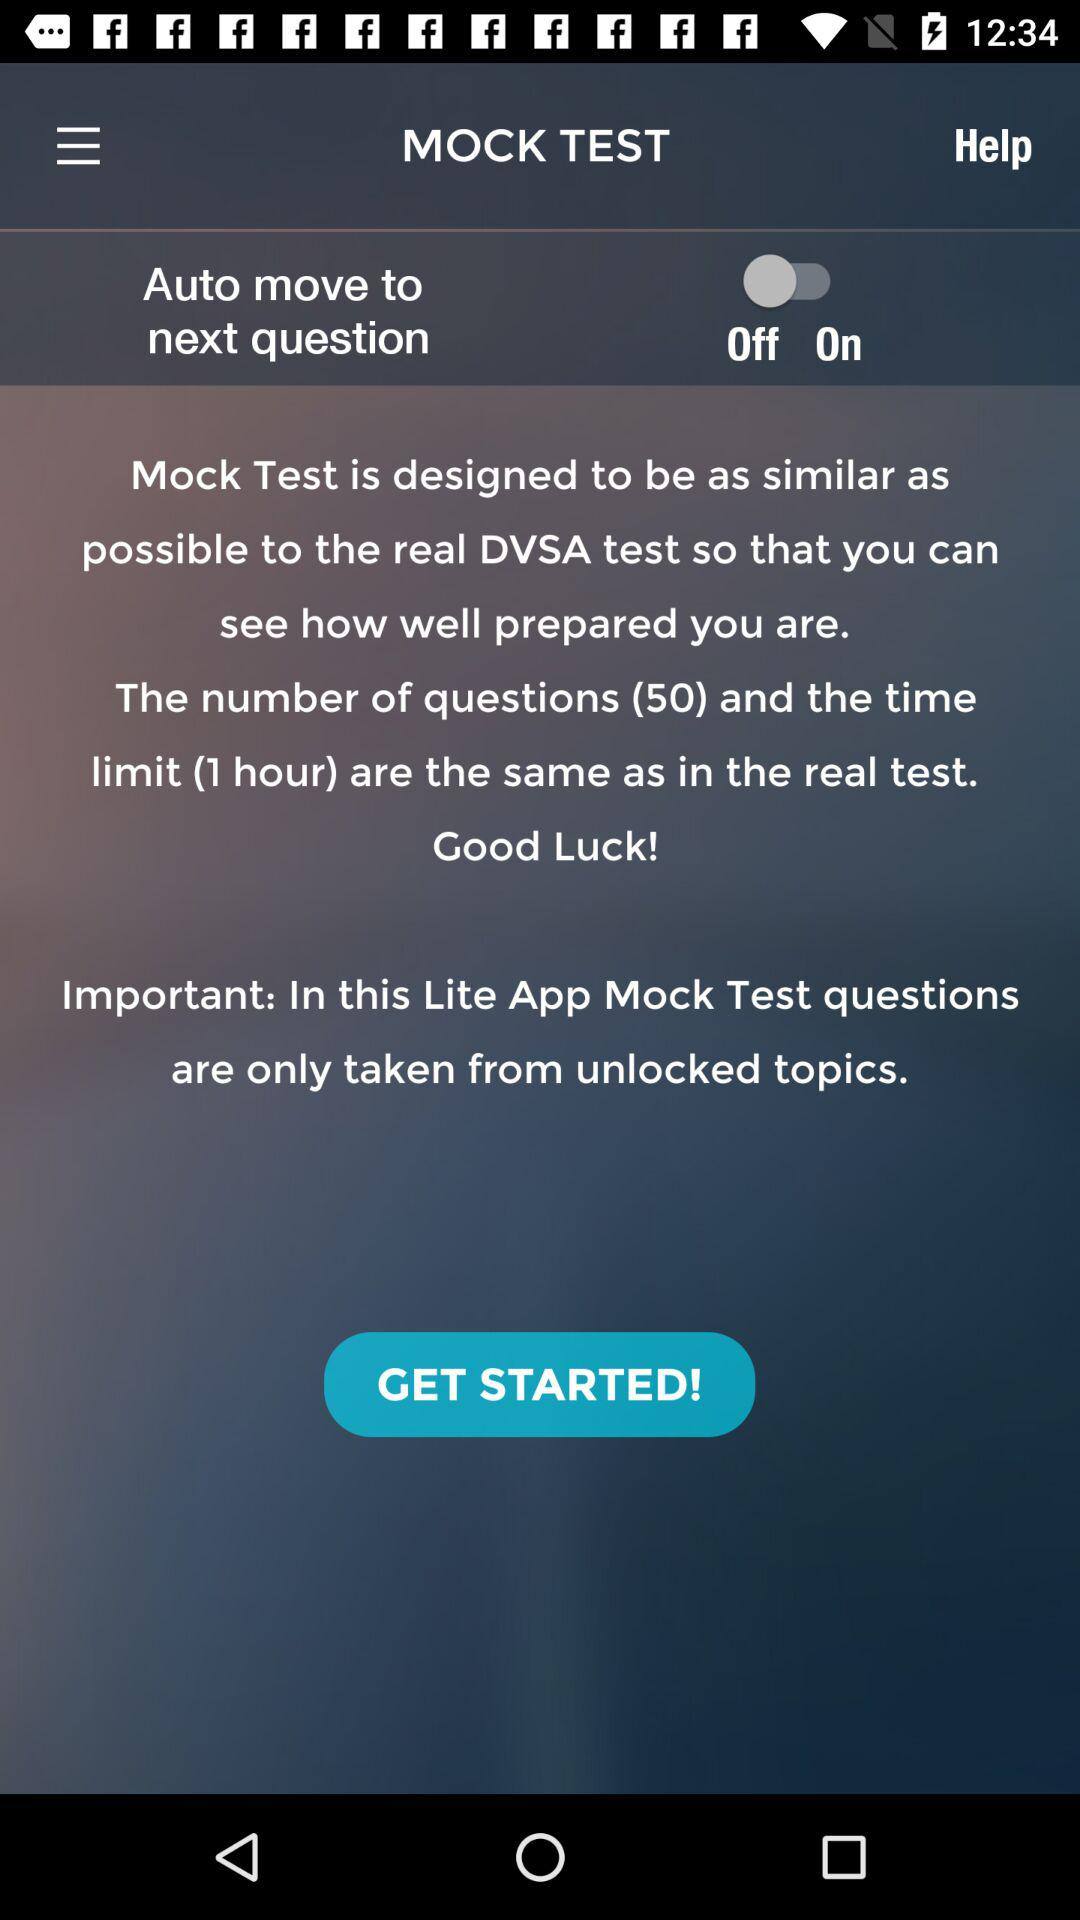How many questions are in the mock test?
Answer the question using a single word or phrase. 50 